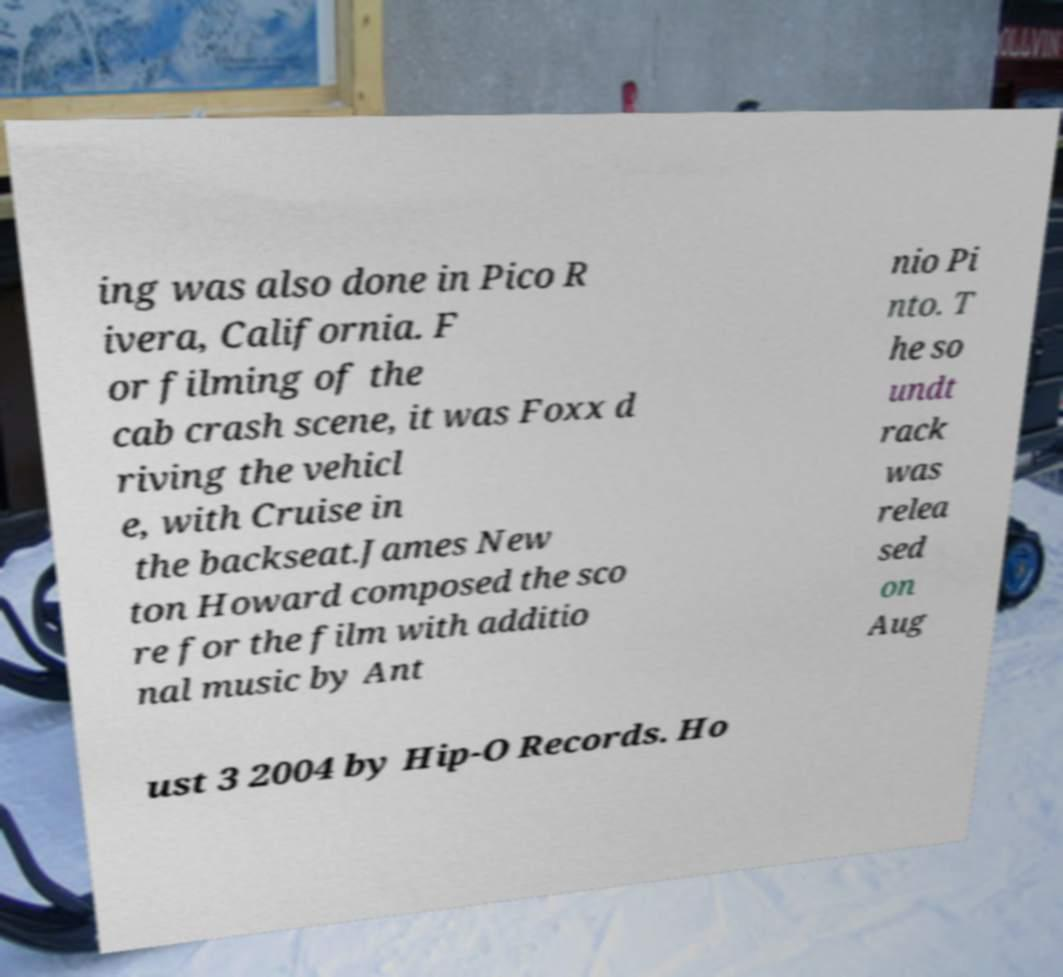What messages or text are displayed in this image? I need them in a readable, typed format. ing was also done in Pico R ivera, California. F or filming of the cab crash scene, it was Foxx d riving the vehicl e, with Cruise in the backseat.James New ton Howard composed the sco re for the film with additio nal music by Ant nio Pi nto. T he so undt rack was relea sed on Aug ust 3 2004 by Hip-O Records. Ho 